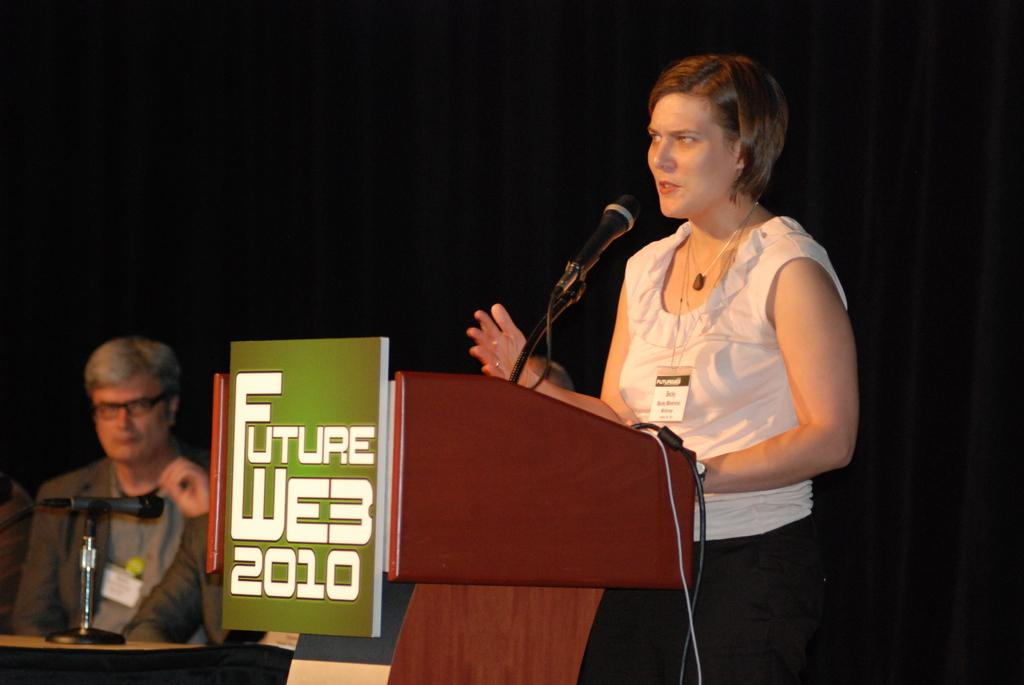What is the woman in the image doing? A woman is standing in the image. What object is present that is typically used for amplifying sound? There is a microphone in the image. What are the two men in the image doing? Two men are sitting in the image. What type of structure can be seen in the image? There is a wooden structure in the image. What color is the background of the image? The background of the image is black. What type of joke is the woman telling in the image? There is no indication in the image that the woman is telling a joke, so it cannot be determined from the picture. 